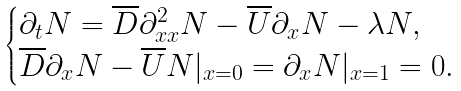Convert formula to latex. <formula><loc_0><loc_0><loc_500><loc_500>\begin{cases} \partial _ { t } N = \overline { D } \partial _ { x x } ^ { 2 } N - \overline { U } \partial _ { x } N - \lambda N , \\ \overline { D } \partial _ { x } N - \overline { U } N | _ { x = 0 } = \partial _ { x } N | _ { x = 1 } = 0 . \end{cases}</formula> 